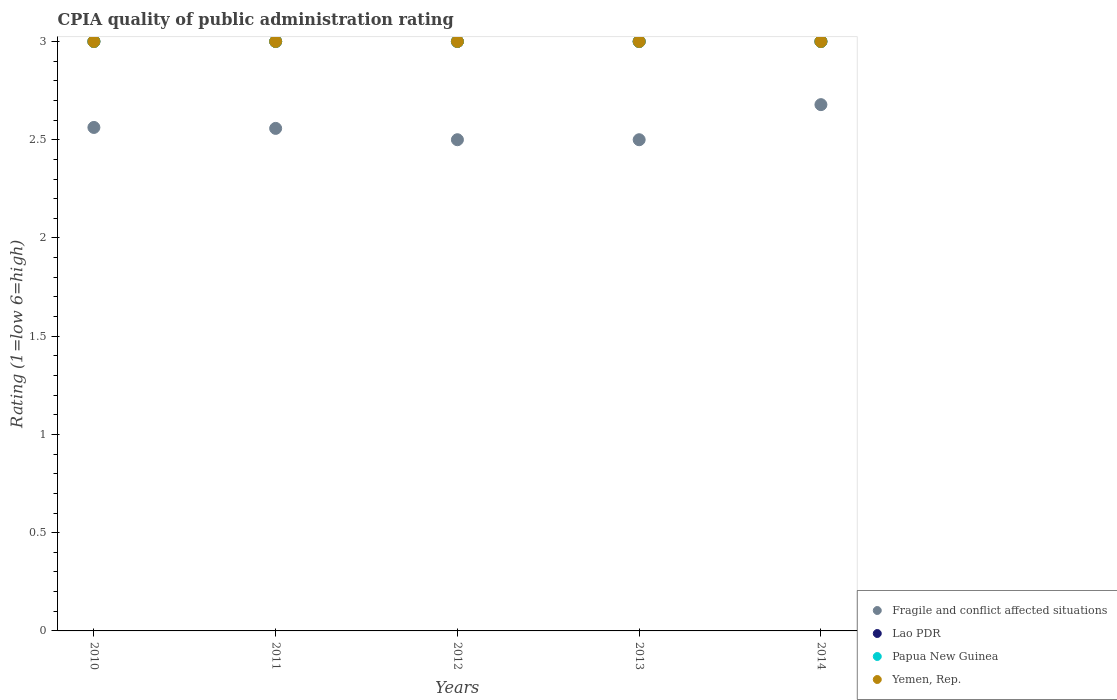How many different coloured dotlines are there?
Ensure brevity in your answer.  4. Is the number of dotlines equal to the number of legend labels?
Offer a terse response. Yes. Across all years, what is the maximum CPIA rating in Yemen, Rep.?
Make the answer very short. 3. Across all years, what is the minimum CPIA rating in Fragile and conflict affected situations?
Provide a succinct answer. 2.5. In which year was the CPIA rating in Lao PDR maximum?
Offer a very short reply. 2010. In which year was the CPIA rating in Lao PDR minimum?
Provide a short and direct response. 2010. What is the total CPIA rating in Yemen, Rep. in the graph?
Offer a very short reply. 15. What is the difference between the CPIA rating in Lao PDR in 2014 and the CPIA rating in Yemen, Rep. in 2012?
Offer a terse response. 0. In the year 2011, what is the difference between the CPIA rating in Lao PDR and CPIA rating in Fragile and conflict affected situations?
Make the answer very short. 0.44. What is the ratio of the CPIA rating in Lao PDR in 2010 to that in 2013?
Your response must be concise. 1. Is the CPIA rating in Lao PDR in 2010 less than that in 2011?
Provide a succinct answer. No. What is the difference between the highest and the second highest CPIA rating in Fragile and conflict affected situations?
Offer a terse response. 0.12. What is the difference between the highest and the lowest CPIA rating in Papua New Guinea?
Offer a terse response. 0. Is the sum of the CPIA rating in Fragile and conflict affected situations in 2010 and 2011 greater than the maximum CPIA rating in Lao PDR across all years?
Ensure brevity in your answer.  Yes. Does the CPIA rating in Yemen, Rep. monotonically increase over the years?
Provide a short and direct response. No. Is the CPIA rating in Fragile and conflict affected situations strictly less than the CPIA rating in Lao PDR over the years?
Your answer should be compact. Yes. How many dotlines are there?
Offer a very short reply. 4. Are the values on the major ticks of Y-axis written in scientific E-notation?
Your answer should be very brief. No. Where does the legend appear in the graph?
Your answer should be very brief. Bottom right. What is the title of the graph?
Keep it short and to the point. CPIA quality of public administration rating. Does "Solomon Islands" appear as one of the legend labels in the graph?
Your response must be concise. No. What is the label or title of the Y-axis?
Your response must be concise. Rating (1=low 6=high). What is the Rating (1=low 6=high) in Fragile and conflict affected situations in 2010?
Keep it short and to the point. 2.56. What is the Rating (1=low 6=high) of Lao PDR in 2010?
Keep it short and to the point. 3. What is the Rating (1=low 6=high) in Yemen, Rep. in 2010?
Provide a short and direct response. 3. What is the Rating (1=low 6=high) of Fragile and conflict affected situations in 2011?
Your answer should be compact. 2.56. What is the Rating (1=low 6=high) in Lao PDR in 2011?
Your response must be concise. 3. What is the Rating (1=low 6=high) in Papua New Guinea in 2011?
Your response must be concise. 3. What is the Rating (1=low 6=high) in Yemen, Rep. in 2011?
Offer a very short reply. 3. What is the Rating (1=low 6=high) of Lao PDR in 2012?
Give a very brief answer. 3. What is the Rating (1=low 6=high) of Fragile and conflict affected situations in 2013?
Offer a very short reply. 2.5. What is the Rating (1=low 6=high) of Fragile and conflict affected situations in 2014?
Provide a short and direct response. 2.68. What is the Rating (1=low 6=high) in Lao PDR in 2014?
Provide a short and direct response. 3. Across all years, what is the maximum Rating (1=low 6=high) of Fragile and conflict affected situations?
Provide a short and direct response. 2.68. Across all years, what is the maximum Rating (1=low 6=high) in Papua New Guinea?
Your answer should be very brief. 3. Across all years, what is the minimum Rating (1=low 6=high) in Yemen, Rep.?
Your response must be concise. 3. What is the total Rating (1=low 6=high) in Fragile and conflict affected situations in the graph?
Give a very brief answer. 12.8. What is the total Rating (1=low 6=high) of Papua New Guinea in the graph?
Ensure brevity in your answer.  15. What is the total Rating (1=low 6=high) in Yemen, Rep. in the graph?
Keep it short and to the point. 15. What is the difference between the Rating (1=low 6=high) in Fragile and conflict affected situations in 2010 and that in 2011?
Keep it short and to the point. 0. What is the difference between the Rating (1=low 6=high) of Papua New Guinea in 2010 and that in 2011?
Offer a terse response. 0. What is the difference between the Rating (1=low 6=high) in Fragile and conflict affected situations in 2010 and that in 2012?
Provide a short and direct response. 0.06. What is the difference between the Rating (1=low 6=high) in Lao PDR in 2010 and that in 2012?
Ensure brevity in your answer.  0. What is the difference between the Rating (1=low 6=high) in Papua New Guinea in 2010 and that in 2012?
Keep it short and to the point. 0. What is the difference between the Rating (1=low 6=high) of Fragile and conflict affected situations in 2010 and that in 2013?
Provide a succinct answer. 0.06. What is the difference between the Rating (1=low 6=high) in Lao PDR in 2010 and that in 2013?
Ensure brevity in your answer.  0. What is the difference between the Rating (1=low 6=high) in Yemen, Rep. in 2010 and that in 2013?
Provide a succinct answer. 0. What is the difference between the Rating (1=low 6=high) in Fragile and conflict affected situations in 2010 and that in 2014?
Provide a short and direct response. -0.12. What is the difference between the Rating (1=low 6=high) in Lao PDR in 2010 and that in 2014?
Offer a terse response. 0. What is the difference between the Rating (1=low 6=high) of Fragile and conflict affected situations in 2011 and that in 2012?
Your answer should be very brief. 0.06. What is the difference between the Rating (1=low 6=high) in Lao PDR in 2011 and that in 2012?
Offer a terse response. 0. What is the difference between the Rating (1=low 6=high) of Fragile and conflict affected situations in 2011 and that in 2013?
Offer a terse response. 0.06. What is the difference between the Rating (1=low 6=high) in Lao PDR in 2011 and that in 2013?
Your answer should be compact. 0. What is the difference between the Rating (1=low 6=high) of Papua New Guinea in 2011 and that in 2013?
Offer a terse response. 0. What is the difference between the Rating (1=low 6=high) in Yemen, Rep. in 2011 and that in 2013?
Your answer should be compact. 0. What is the difference between the Rating (1=low 6=high) in Fragile and conflict affected situations in 2011 and that in 2014?
Keep it short and to the point. -0.12. What is the difference between the Rating (1=low 6=high) of Lao PDR in 2011 and that in 2014?
Give a very brief answer. 0. What is the difference between the Rating (1=low 6=high) of Papua New Guinea in 2011 and that in 2014?
Make the answer very short. 0. What is the difference between the Rating (1=low 6=high) of Yemen, Rep. in 2011 and that in 2014?
Your response must be concise. 0. What is the difference between the Rating (1=low 6=high) in Fragile and conflict affected situations in 2012 and that in 2013?
Ensure brevity in your answer.  0. What is the difference between the Rating (1=low 6=high) of Lao PDR in 2012 and that in 2013?
Give a very brief answer. 0. What is the difference between the Rating (1=low 6=high) of Yemen, Rep. in 2012 and that in 2013?
Keep it short and to the point. 0. What is the difference between the Rating (1=low 6=high) of Fragile and conflict affected situations in 2012 and that in 2014?
Your response must be concise. -0.18. What is the difference between the Rating (1=low 6=high) of Papua New Guinea in 2012 and that in 2014?
Give a very brief answer. 0. What is the difference between the Rating (1=low 6=high) in Yemen, Rep. in 2012 and that in 2014?
Your response must be concise. 0. What is the difference between the Rating (1=low 6=high) of Fragile and conflict affected situations in 2013 and that in 2014?
Provide a succinct answer. -0.18. What is the difference between the Rating (1=low 6=high) of Papua New Guinea in 2013 and that in 2014?
Your response must be concise. 0. What is the difference between the Rating (1=low 6=high) of Fragile and conflict affected situations in 2010 and the Rating (1=low 6=high) of Lao PDR in 2011?
Offer a very short reply. -0.44. What is the difference between the Rating (1=low 6=high) of Fragile and conflict affected situations in 2010 and the Rating (1=low 6=high) of Papua New Guinea in 2011?
Ensure brevity in your answer.  -0.44. What is the difference between the Rating (1=low 6=high) in Fragile and conflict affected situations in 2010 and the Rating (1=low 6=high) in Yemen, Rep. in 2011?
Offer a terse response. -0.44. What is the difference between the Rating (1=low 6=high) in Lao PDR in 2010 and the Rating (1=low 6=high) in Yemen, Rep. in 2011?
Provide a succinct answer. 0. What is the difference between the Rating (1=low 6=high) in Papua New Guinea in 2010 and the Rating (1=low 6=high) in Yemen, Rep. in 2011?
Give a very brief answer. 0. What is the difference between the Rating (1=low 6=high) in Fragile and conflict affected situations in 2010 and the Rating (1=low 6=high) in Lao PDR in 2012?
Make the answer very short. -0.44. What is the difference between the Rating (1=low 6=high) of Fragile and conflict affected situations in 2010 and the Rating (1=low 6=high) of Papua New Guinea in 2012?
Offer a terse response. -0.44. What is the difference between the Rating (1=low 6=high) in Fragile and conflict affected situations in 2010 and the Rating (1=low 6=high) in Yemen, Rep. in 2012?
Provide a short and direct response. -0.44. What is the difference between the Rating (1=low 6=high) of Lao PDR in 2010 and the Rating (1=low 6=high) of Papua New Guinea in 2012?
Ensure brevity in your answer.  0. What is the difference between the Rating (1=low 6=high) in Fragile and conflict affected situations in 2010 and the Rating (1=low 6=high) in Lao PDR in 2013?
Provide a short and direct response. -0.44. What is the difference between the Rating (1=low 6=high) in Fragile and conflict affected situations in 2010 and the Rating (1=low 6=high) in Papua New Guinea in 2013?
Keep it short and to the point. -0.44. What is the difference between the Rating (1=low 6=high) of Fragile and conflict affected situations in 2010 and the Rating (1=low 6=high) of Yemen, Rep. in 2013?
Offer a terse response. -0.44. What is the difference between the Rating (1=low 6=high) in Lao PDR in 2010 and the Rating (1=low 6=high) in Papua New Guinea in 2013?
Your answer should be very brief. 0. What is the difference between the Rating (1=low 6=high) of Fragile and conflict affected situations in 2010 and the Rating (1=low 6=high) of Lao PDR in 2014?
Offer a very short reply. -0.44. What is the difference between the Rating (1=low 6=high) in Fragile and conflict affected situations in 2010 and the Rating (1=low 6=high) in Papua New Guinea in 2014?
Offer a very short reply. -0.44. What is the difference between the Rating (1=low 6=high) in Fragile and conflict affected situations in 2010 and the Rating (1=low 6=high) in Yemen, Rep. in 2014?
Your response must be concise. -0.44. What is the difference between the Rating (1=low 6=high) in Lao PDR in 2010 and the Rating (1=low 6=high) in Papua New Guinea in 2014?
Keep it short and to the point. 0. What is the difference between the Rating (1=low 6=high) in Lao PDR in 2010 and the Rating (1=low 6=high) in Yemen, Rep. in 2014?
Offer a very short reply. 0. What is the difference between the Rating (1=low 6=high) of Fragile and conflict affected situations in 2011 and the Rating (1=low 6=high) of Lao PDR in 2012?
Ensure brevity in your answer.  -0.44. What is the difference between the Rating (1=low 6=high) in Fragile and conflict affected situations in 2011 and the Rating (1=low 6=high) in Papua New Guinea in 2012?
Ensure brevity in your answer.  -0.44. What is the difference between the Rating (1=low 6=high) in Fragile and conflict affected situations in 2011 and the Rating (1=low 6=high) in Yemen, Rep. in 2012?
Provide a succinct answer. -0.44. What is the difference between the Rating (1=low 6=high) of Lao PDR in 2011 and the Rating (1=low 6=high) of Papua New Guinea in 2012?
Provide a succinct answer. 0. What is the difference between the Rating (1=low 6=high) of Lao PDR in 2011 and the Rating (1=low 6=high) of Yemen, Rep. in 2012?
Make the answer very short. 0. What is the difference between the Rating (1=low 6=high) of Papua New Guinea in 2011 and the Rating (1=low 6=high) of Yemen, Rep. in 2012?
Give a very brief answer. 0. What is the difference between the Rating (1=low 6=high) in Fragile and conflict affected situations in 2011 and the Rating (1=low 6=high) in Lao PDR in 2013?
Your response must be concise. -0.44. What is the difference between the Rating (1=low 6=high) of Fragile and conflict affected situations in 2011 and the Rating (1=low 6=high) of Papua New Guinea in 2013?
Keep it short and to the point. -0.44. What is the difference between the Rating (1=low 6=high) of Fragile and conflict affected situations in 2011 and the Rating (1=low 6=high) of Yemen, Rep. in 2013?
Give a very brief answer. -0.44. What is the difference between the Rating (1=low 6=high) of Lao PDR in 2011 and the Rating (1=low 6=high) of Yemen, Rep. in 2013?
Your response must be concise. 0. What is the difference between the Rating (1=low 6=high) of Fragile and conflict affected situations in 2011 and the Rating (1=low 6=high) of Lao PDR in 2014?
Your answer should be very brief. -0.44. What is the difference between the Rating (1=low 6=high) in Fragile and conflict affected situations in 2011 and the Rating (1=low 6=high) in Papua New Guinea in 2014?
Make the answer very short. -0.44. What is the difference between the Rating (1=low 6=high) of Fragile and conflict affected situations in 2011 and the Rating (1=low 6=high) of Yemen, Rep. in 2014?
Ensure brevity in your answer.  -0.44. What is the difference between the Rating (1=low 6=high) in Lao PDR in 2011 and the Rating (1=low 6=high) in Papua New Guinea in 2014?
Provide a succinct answer. 0. What is the difference between the Rating (1=low 6=high) of Papua New Guinea in 2012 and the Rating (1=low 6=high) of Yemen, Rep. in 2013?
Your answer should be very brief. 0. What is the difference between the Rating (1=low 6=high) of Fragile and conflict affected situations in 2012 and the Rating (1=low 6=high) of Papua New Guinea in 2014?
Your answer should be compact. -0.5. What is the difference between the Rating (1=low 6=high) of Fragile and conflict affected situations in 2012 and the Rating (1=low 6=high) of Yemen, Rep. in 2014?
Provide a short and direct response. -0.5. What is the difference between the Rating (1=low 6=high) in Lao PDR in 2012 and the Rating (1=low 6=high) in Papua New Guinea in 2014?
Make the answer very short. 0. What is the difference between the Rating (1=low 6=high) in Lao PDR in 2012 and the Rating (1=low 6=high) in Yemen, Rep. in 2014?
Provide a short and direct response. 0. What is the difference between the Rating (1=low 6=high) of Papua New Guinea in 2013 and the Rating (1=low 6=high) of Yemen, Rep. in 2014?
Offer a very short reply. 0. What is the average Rating (1=low 6=high) of Fragile and conflict affected situations per year?
Provide a succinct answer. 2.56. What is the average Rating (1=low 6=high) in Lao PDR per year?
Provide a short and direct response. 3. What is the average Rating (1=low 6=high) of Papua New Guinea per year?
Offer a very short reply. 3. What is the average Rating (1=low 6=high) in Yemen, Rep. per year?
Offer a terse response. 3. In the year 2010, what is the difference between the Rating (1=low 6=high) in Fragile and conflict affected situations and Rating (1=low 6=high) in Lao PDR?
Offer a very short reply. -0.44. In the year 2010, what is the difference between the Rating (1=low 6=high) of Fragile and conflict affected situations and Rating (1=low 6=high) of Papua New Guinea?
Offer a terse response. -0.44. In the year 2010, what is the difference between the Rating (1=low 6=high) in Fragile and conflict affected situations and Rating (1=low 6=high) in Yemen, Rep.?
Ensure brevity in your answer.  -0.44. In the year 2010, what is the difference between the Rating (1=low 6=high) of Lao PDR and Rating (1=low 6=high) of Papua New Guinea?
Give a very brief answer. 0. In the year 2010, what is the difference between the Rating (1=low 6=high) in Lao PDR and Rating (1=low 6=high) in Yemen, Rep.?
Ensure brevity in your answer.  0. In the year 2010, what is the difference between the Rating (1=low 6=high) in Papua New Guinea and Rating (1=low 6=high) in Yemen, Rep.?
Give a very brief answer. 0. In the year 2011, what is the difference between the Rating (1=low 6=high) of Fragile and conflict affected situations and Rating (1=low 6=high) of Lao PDR?
Your answer should be compact. -0.44. In the year 2011, what is the difference between the Rating (1=low 6=high) of Fragile and conflict affected situations and Rating (1=low 6=high) of Papua New Guinea?
Your answer should be very brief. -0.44. In the year 2011, what is the difference between the Rating (1=low 6=high) in Fragile and conflict affected situations and Rating (1=low 6=high) in Yemen, Rep.?
Provide a succinct answer. -0.44. In the year 2011, what is the difference between the Rating (1=low 6=high) in Lao PDR and Rating (1=low 6=high) in Yemen, Rep.?
Give a very brief answer. 0. In the year 2012, what is the difference between the Rating (1=low 6=high) of Fragile and conflict affected situations and Rating (1=low 6=high) of Lao PDR?
Provide a succinct answer. -0.5. In the year 2012, what is the difference between the Rating (1=low 6=high) in Fragile and conflict affected situations and Rating (1=low 6=high) in Papua New Guinea?
Offer a terse response. -0.5. In the year 2012, what is the difference between the Rating (1=low 6=high) of Fragile and conflict affected situations and Rating (1=low 6=high) of Yemen, Rep.?
Offer a very short reply. -0.5. In the year 2012, what is the difference between the Rating (1=low 6=high) of Lao PDR and Rating (1=low 6=high) of Yemen, Rep.?
Your answer should be compact. 0. In the year 2012, what is the difference between the Rating (1=low 6=high) of Papua New Guinea and Rating (1=low 6=high) of Yemen, Rep.?
Give a very brief answer. 0. In the year 2013, what is the difference between the Rating (1=low 6=high) of Fragile and conflict affected situations and Rating (1=low 6=high) of Lao PDR?
Your response must be concise. -0.5. In the year 2013, what is the difference between the Rating (1=low 6=high) of Fragile and conflict affected situations and Rating (1=low 6=high) of Yemen, Rep.?
Provide a short and direct response. -0.5. In the year 2013, what is the difference between the Rating (1=low 6=high) in Lao PDR and Rating (1=low 6=high) in Yemen, Rep.?
Offer a terse response. 0. In the year 2014, what is the difference between the Rating (1=low 6=high) in Fragile and conflict affected situations and Rating (1=low 6=high) in Lao PDR?
Give a very brief answer. -0.32. In the year 2014, what is the difference between the Rating (1=low 6=high) of Fragile and conflict affected situations and Rating (1=low 6=high) of Papua New Guinea?
Offer a terse response. -0.32. In the year 2014, what is the difference between the Rating (1=low 6=high) in Fragile and conflict affected situations and Rating (1=low 6=high) in Yemen, Rep.?
Make the answer very short. -0.32. In the year 2014, what is the difference between the Rating (1=low 6=high) of Lao PDR and Rating (1=low 6=high) of Papua New Guinea?
Offer a very short reply. 0. In the year 2014, what is the difference between the Rating (1=low 6=high) in Lao PDR and Rating (1=low 6=high) in Yemen, Rep.?
Keep it short and to the point. 0. What is the ratio of the Rating (1=low 6=high) in Papua New Guinea in 2010 to that in 2011?
Offer a terse response. 1. What is the ratio of the Rating (1=low 6=high) in Lao PDR in 2010 to that in 2012?
Make the answer very short. 1. What is the ratio of the Rating (1=low 6=high) of Papua New Guinea in 2010 to that in 2012?
Give a very brief answer. 1. What is the ratio of the Rating (1=low 6=high) of Yemen, Rep. in 2010 to that in 2012?
Offer a very short reply. 1. What is the ratio of the Rating (1=low 6=high) of Lao PDR in 2010 to that in 2013?
Your answer should be very brief. 1. What is the ratio of the Rating (1=low 6=high) of Yemen, Rep. in 2010 to that in 2013?
Keep it short and to the point. 1. What is the ratio of the Rating (1=low 6=high) of Fragile and conflict affected situations in 2010 to that in 2014?
Your response must be concise. 0.96. What is the ratio of the Rating (1=low 6=high) of Lao PDR in 2010 to that in 2014?
Offer a terse response. 1. What is the ratio of the Rating (1=low 6=high) in Fragile and conflict affected situations in 2011 to that in 2012?
Your answer should be compact. 1.02. What is the ratio of the Rating (1=low 6=high) of Papua New Guinea in 2011 to that in 2012?
Your answer should be very brief. 1. What is the ratio of the Rating (1=low 6=high) in Fragile and conflict affected situations in 2011 to that in 2013?
Offer a terse response. 1.02. What is the ratio of the Rating (1=low 6=high) of Papua New Guinea in 2011 to that in 2013?
Make the answer very short. 1. What is the ratio of the Rating (1=low 6=high) of Fragile and conflict affected situations in 2011 to that in 2014?
Provide a succinct answer. 0.95. What is the ratio of the Rating (1=low 6=high) of Lao PDR in 2011 to that in 2014?
Make the answer very short. 1. What is the ratio of the Rating (1=low 6=high) in Yemen, Rep. in 2011 to that in 2014?
Your answer should be very brief. 1. What is the ratio of the Rating (1=low 6=high) in Lao PDR in 2012 to that in 2013?
Your answer should be very brief. 1. What is the ratio of the Rating (1=low 6=high) in Papua New Guinea in 2012 to that in 2013?
Your response must be concise. 1. What is the ratio of the Rating (1=low 6=high) in Fragile and conflict affected situations in 2012 to that in 2014?
Ensure brevity in your answer.  0.93. What is the ratio of the Rating (1=low 6=high) in Papua New Guinea in 2012 to that in 2014?
Your answer should be compact. 1. What is the ratio of the Rating (1=low 6=high) of Yemen, Rep. in 2012 to that in 2014?
Offer a terse response. 1. What is the ratio of the Rating (1=low 6=high) in Fragile and conflict affected situations in 2013 to that in 2014?
Make the answer very short. 0.93. What is the ratio of the Rating (1=low 6=high) in Papua New Guinea in 2013 to that in 2014?
Give a very brief answer. 1. What is the difference between the highest and the second highest Rating (1=low 6=high) in Fragile and conflict affected situations?
Ensure brevity in your answer.  0.12. What is the difference between the highest and the second highest Rating (1=low 6=high) of Lao PDR?
Keep it short and to the point. 0. What is the difference between the highest and the second highest Rating (1=low 6=high) in Papua New Guinea?
Make the answer very short. 0. What is the difference between the highest and the second highest Rating (1=low 6=high) of Yemen, Rep.?
Offer a very short reply. 0. What is the difference between the highest and the lowest Rating (1=low 6=high) of Fragile and conflict affected situations?
Your answer should be compact. 0.18. What is the difference between the highest and the lowest Rating (1=low 6=high) in Papua New Guinea?
Keep it short and to the point. 0. 